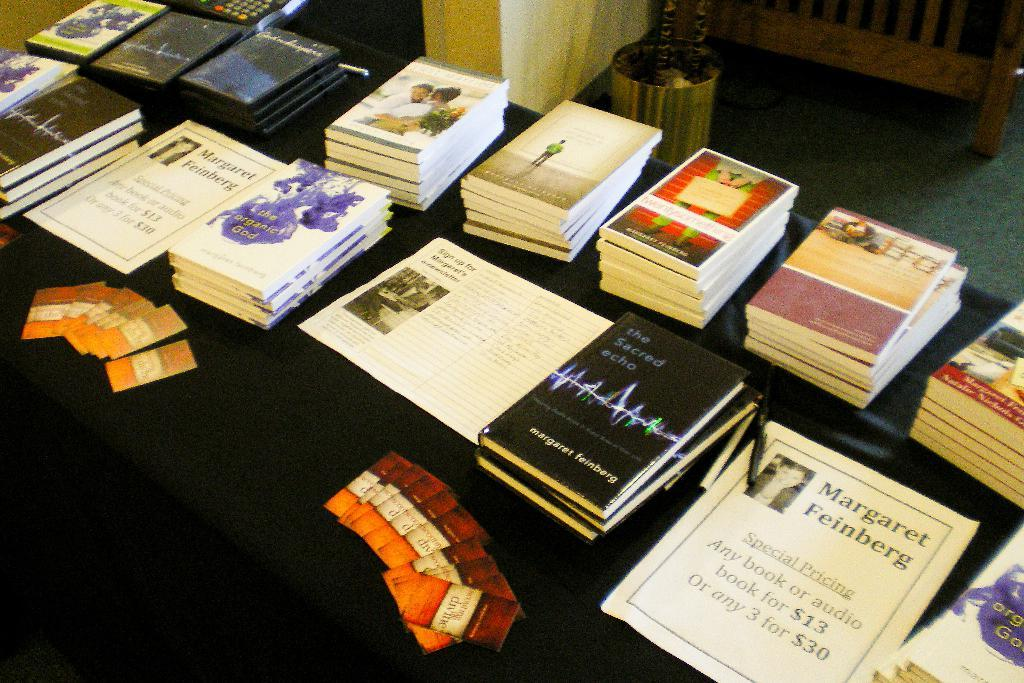<image>
Share a concise interpretation of the image provided. A table covered in books written by Margaret Feinberg. 